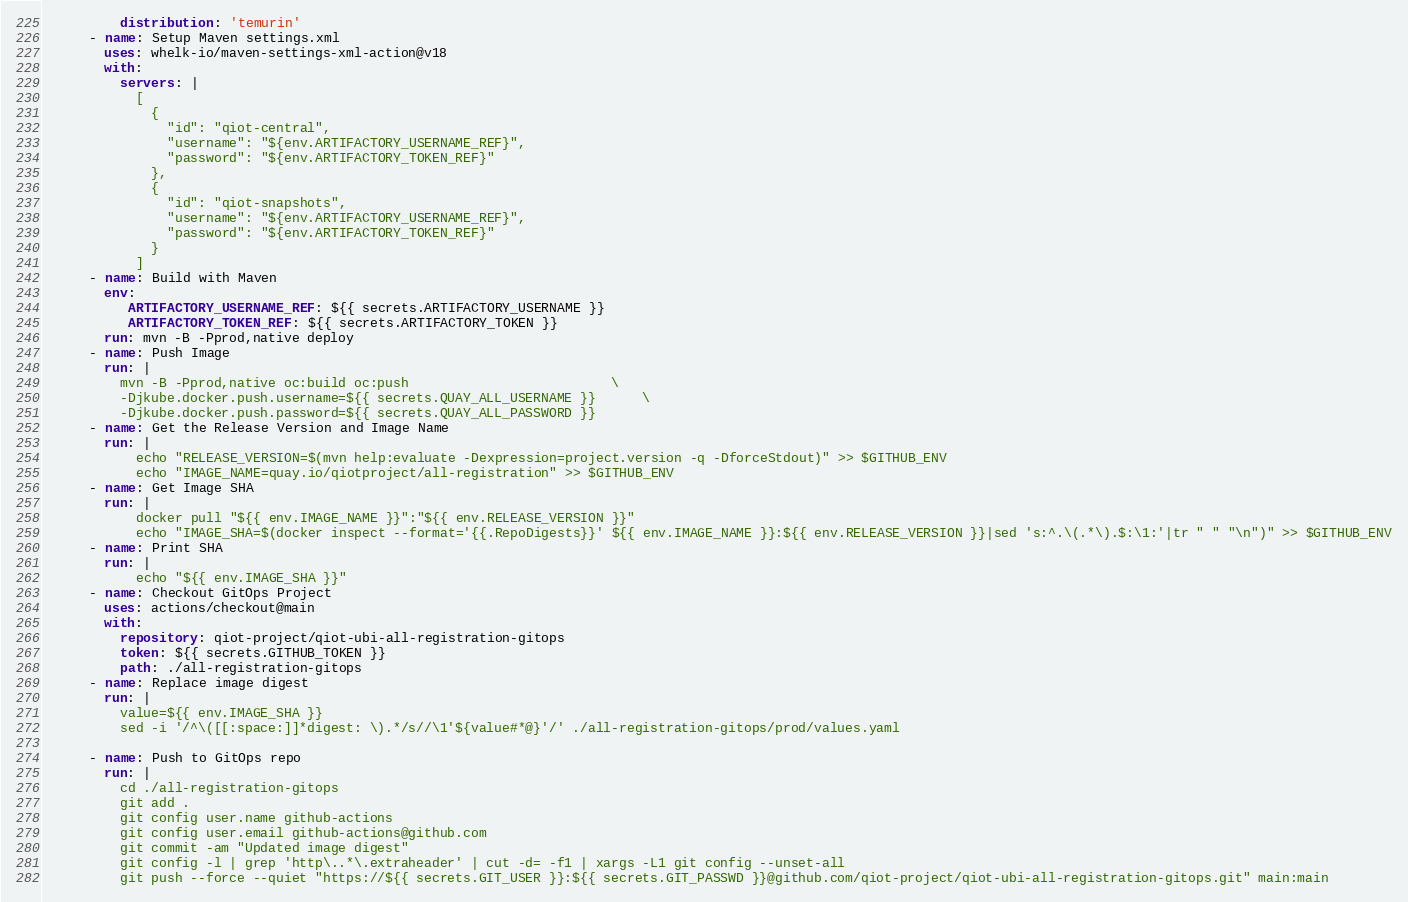<code> <loc_0><loc_0><loc_500><loc_500><_YAML_>          distribution: 'temurin'
      - name: Setup Maven settings.xml
        uses: whelk-io/maven-settings-xml-action@v18
        with:
          servers: |
            [
              {
                "id": "qiot-central",
                "username": "${env.ARTIFACTORY_USERNAME_REF}",
                "password": "${env.ARTIFACTORY_TOKEN_REF}"
              },
              {
                "id": "qiot-snapshots",
                "username": "${env.ARTIFACTORY_USERNAME_REF}",
                "password": "${env.ARTIFACTORY_TOKEN_REF}"
              }
            ]
      - name: Build with Maven
        env:
           ARTIFACTORY_USERNAME_REF: ${{ secrets.ARTIFACTORY_USERNAME }}
           ARTIFACTORY_TOKEN_REF: ${{ secrets.ARTIFACTORY_TOKEN }}
        run: mvn -B -Pprod,native deploy
      - name: Push Image
        run: |
          mvn -B -Pprod,native oc:build oc:push                          \
          -Djkube.docker.push.username=${{ secrets.QUAY_ALL_USERNAME }}      \
          -Djkube.docker.push.password=${{ secrets.QUAY_ALL_PASSWORD }}
      - name: Get the Release Version and Image Name
        run: |
            echo "RELEASE_VERSION=$(mvn help:evaluate -Dexpression=project.version -q -DforceStdout)" >> $GITHUB_ENV
            echo "IMAGE_NAME=quay.io/qiotproject/all-registration" >> $GITHUB_ENV
      - name: Get Image SHA
        run: |
            docker pull "${{ env.IMAGE_NAME }}":"${{ env.RELEASE_VERSION }}"
            echo "IMAGE_SHA=$(docker inspect --format='{{.RepoDigests}}' ${{ env.IMAGE_NAME }}:${{ env.RELEASE_VERSION }}|sed 's:^.\(.*\).$:\1:'|tr " " "\n")" >> $GITHUB_ENV
      - name: Print SHA
        run: |
            echo "${{ env.IMAGE_SHA }}"
      - name: Checkout GitOps Project
        uses: actions/checkout@main
        with: 
          repository: qiot-project/qiot-ubi-all-registration-gitops
          token: ${{ secrets.GITHUB_TOKEN }}
          path: ./all-registration-gitops
      - name: Replace image digest
        run: |
          value=${{ env.IMAGE_SHA }}
          sed -i '/^\([[:space:]]*digest: \).*/s//\1'${value#*@}'/' ./all-registration-gitops/prod/values.yaml

      - name: Push to GitOps repo
        run: |
          cd ./all-registration-gitops
          git add .
          git config user.name github-actions
          git config user.email github-actions@github.com
          git commit -am "Updated image digest"
          git config -l | grep 'http\..*\.extraheader' | cut -d= -f1 | xargs -L1 git config --unset-all
          git push --force --quiet "https://${{ secrets.GIT_USER }}:${{ secrets.GIT_PASSWD }}@github.com/qiot-project/qiot-ubi-all-registration-gitops.git" main:main
</code> 